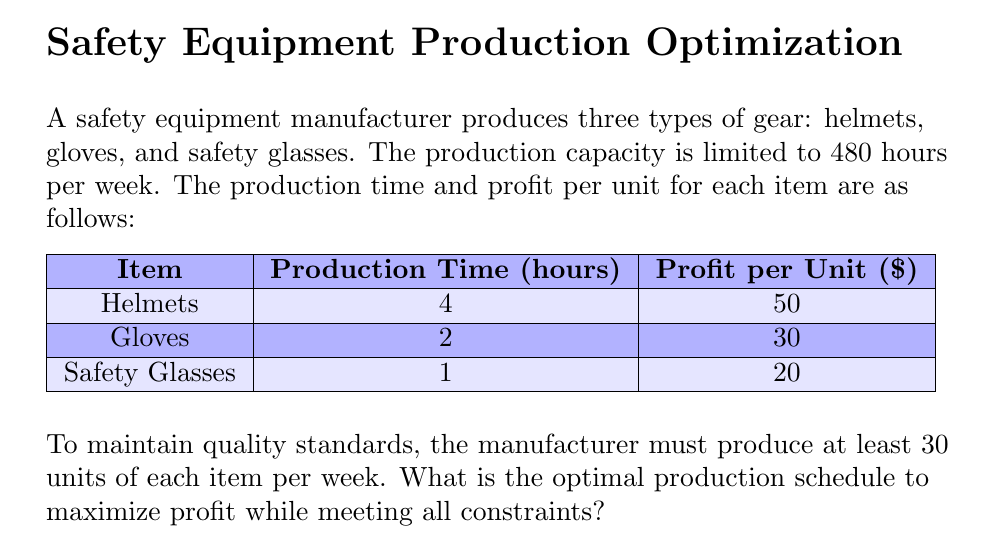Show me your answer to this math problem. Let's solve this problem using linear programming:

1) Define variables:
   Let $x$ = number of helmets
       $y$ = number of gloves
       $z$ = number of safety glasses

2) Objective function (maximize profit):
   $$\text{Maximize } 50x + 30y + 20z$$

3) Constraints:
   a) Production time: $4x + 2y + z \leq 480$
   b) Minimum production: $x \geq 30, y \geq 30, z \geq 30$
   c) Non-negativity: $x, y, z \geq 0$

4) Solve using the simplex method or linear programming software.

5) The optimal solution is:
   $x = 30$ (helmets)
   $y = 30$ (gloves)
   $z = 330$ (safety glasses)

6) Verify constraints:
   a) Production time: $4(30) + 2(30) + 330 = 480$ hours (meets constraint)
   b) Minimum production: All items meet or exceed 30 units
   c) Non-negativity: All values are positive

7) Calculate maximum profit:
   $$50(30) + 30(30) + 20(330) = 1500 + 900 + 6600 = \$9000$$

This production schedule maximizes profit while meeting all quality and production constraints.
Answer: 30 helmets, 30 gloves, 330 safety glasses; $9000 profit 